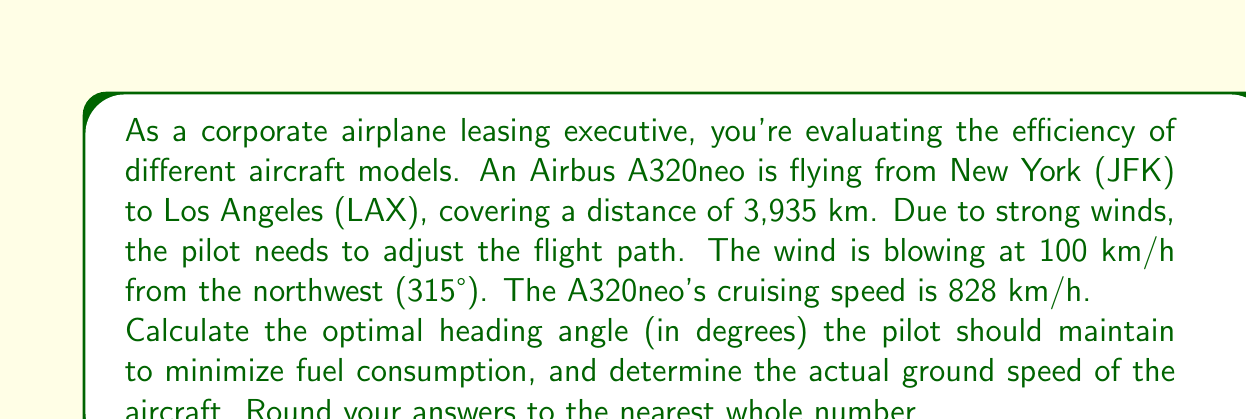Give your solution to this math problem. To solve this problem, we'll use vector analysis and trigonometry. Let's break it down step-by-step:

1) First, let's define our vectors:
   - Aircraft velocity: $\vec{v}_a = 828$ km/h in the direction of the heading angle $\theta$
   - Wind velocity: $\vec{v}_w = 100$ km/h from 315° (northwest)
   - Ground velocity: $\vec{v}_g = \vec{v}_a + \vec{v}_w$

2) We want the ground velocity to be in the direction of the flight path (from JFK to LAX). This means the y-component of $\vec{v}_g$ should be zero.

3) Let's break down the wind vector into x and y components:
   $v_{wx} = 100 \cos(315°) = 100 \cdot (-\frac{\sqrt{2}}{2}) = -70.71$ km/h
   $v_{wy} = 100 \sin(315°) = 100 \cdot (\frac{\sqrt{2}}{2}) = 70.71$ km/h

4) Now, let's set up the equation for the y-component of $\vec{v}_g$ to be zero:
   $v_a \sin(\theta) + v_{wy} = 0$
   $828 \sin(\theta) + 70.71 = 0$
   $\sin(\theta) = -\frac{70.71}{828} = -0.0854$

5) Solve for $\theta$:
   $\theta = \arcsin(-0.0854) = -4.90°$ or $185.10°$

   Since we're flying west, we'll use the positive angle: $185.10°$

6) To find the ground speed, we use the x-component of $\vec{v}_g$:
   $v_g = v_a \cos(\theta) + v_{wx}$
   $v_g = 828 \cos(185.10°) + (-70.71)$
   $v_g = -824.39 - 70.71 = 895.10$ km/h

Rounding to the nearest whole number:
Heading angle: 185°
Ground speed: 895 km/h
Answer: The optimal heading angle is 185°, and the actual ground speed is 895 km/h. 